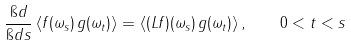Convert formula to latex. <formula><loc_0><loc_0><loc_500><loc_500>\frac { \i d } { \i d s } \left < f ( \omega _ { s } ) \, g ( \omega _ { t } ) \right > = \left < ( L f ) ( \omega _ { s } ) \, g ( \omega _ { t } ) \right > , \quad 0 < t < s</formula> 